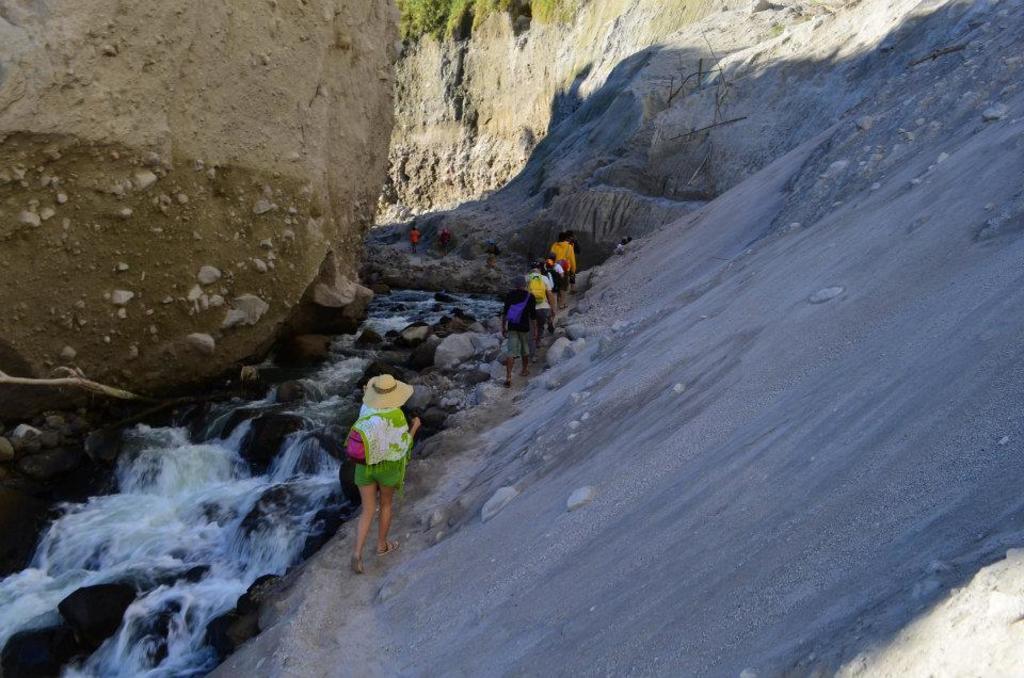Please provide a concise description of this image. In this image I can see people are standing. On the left side I can see water. I can also see rocks and a mountain. 